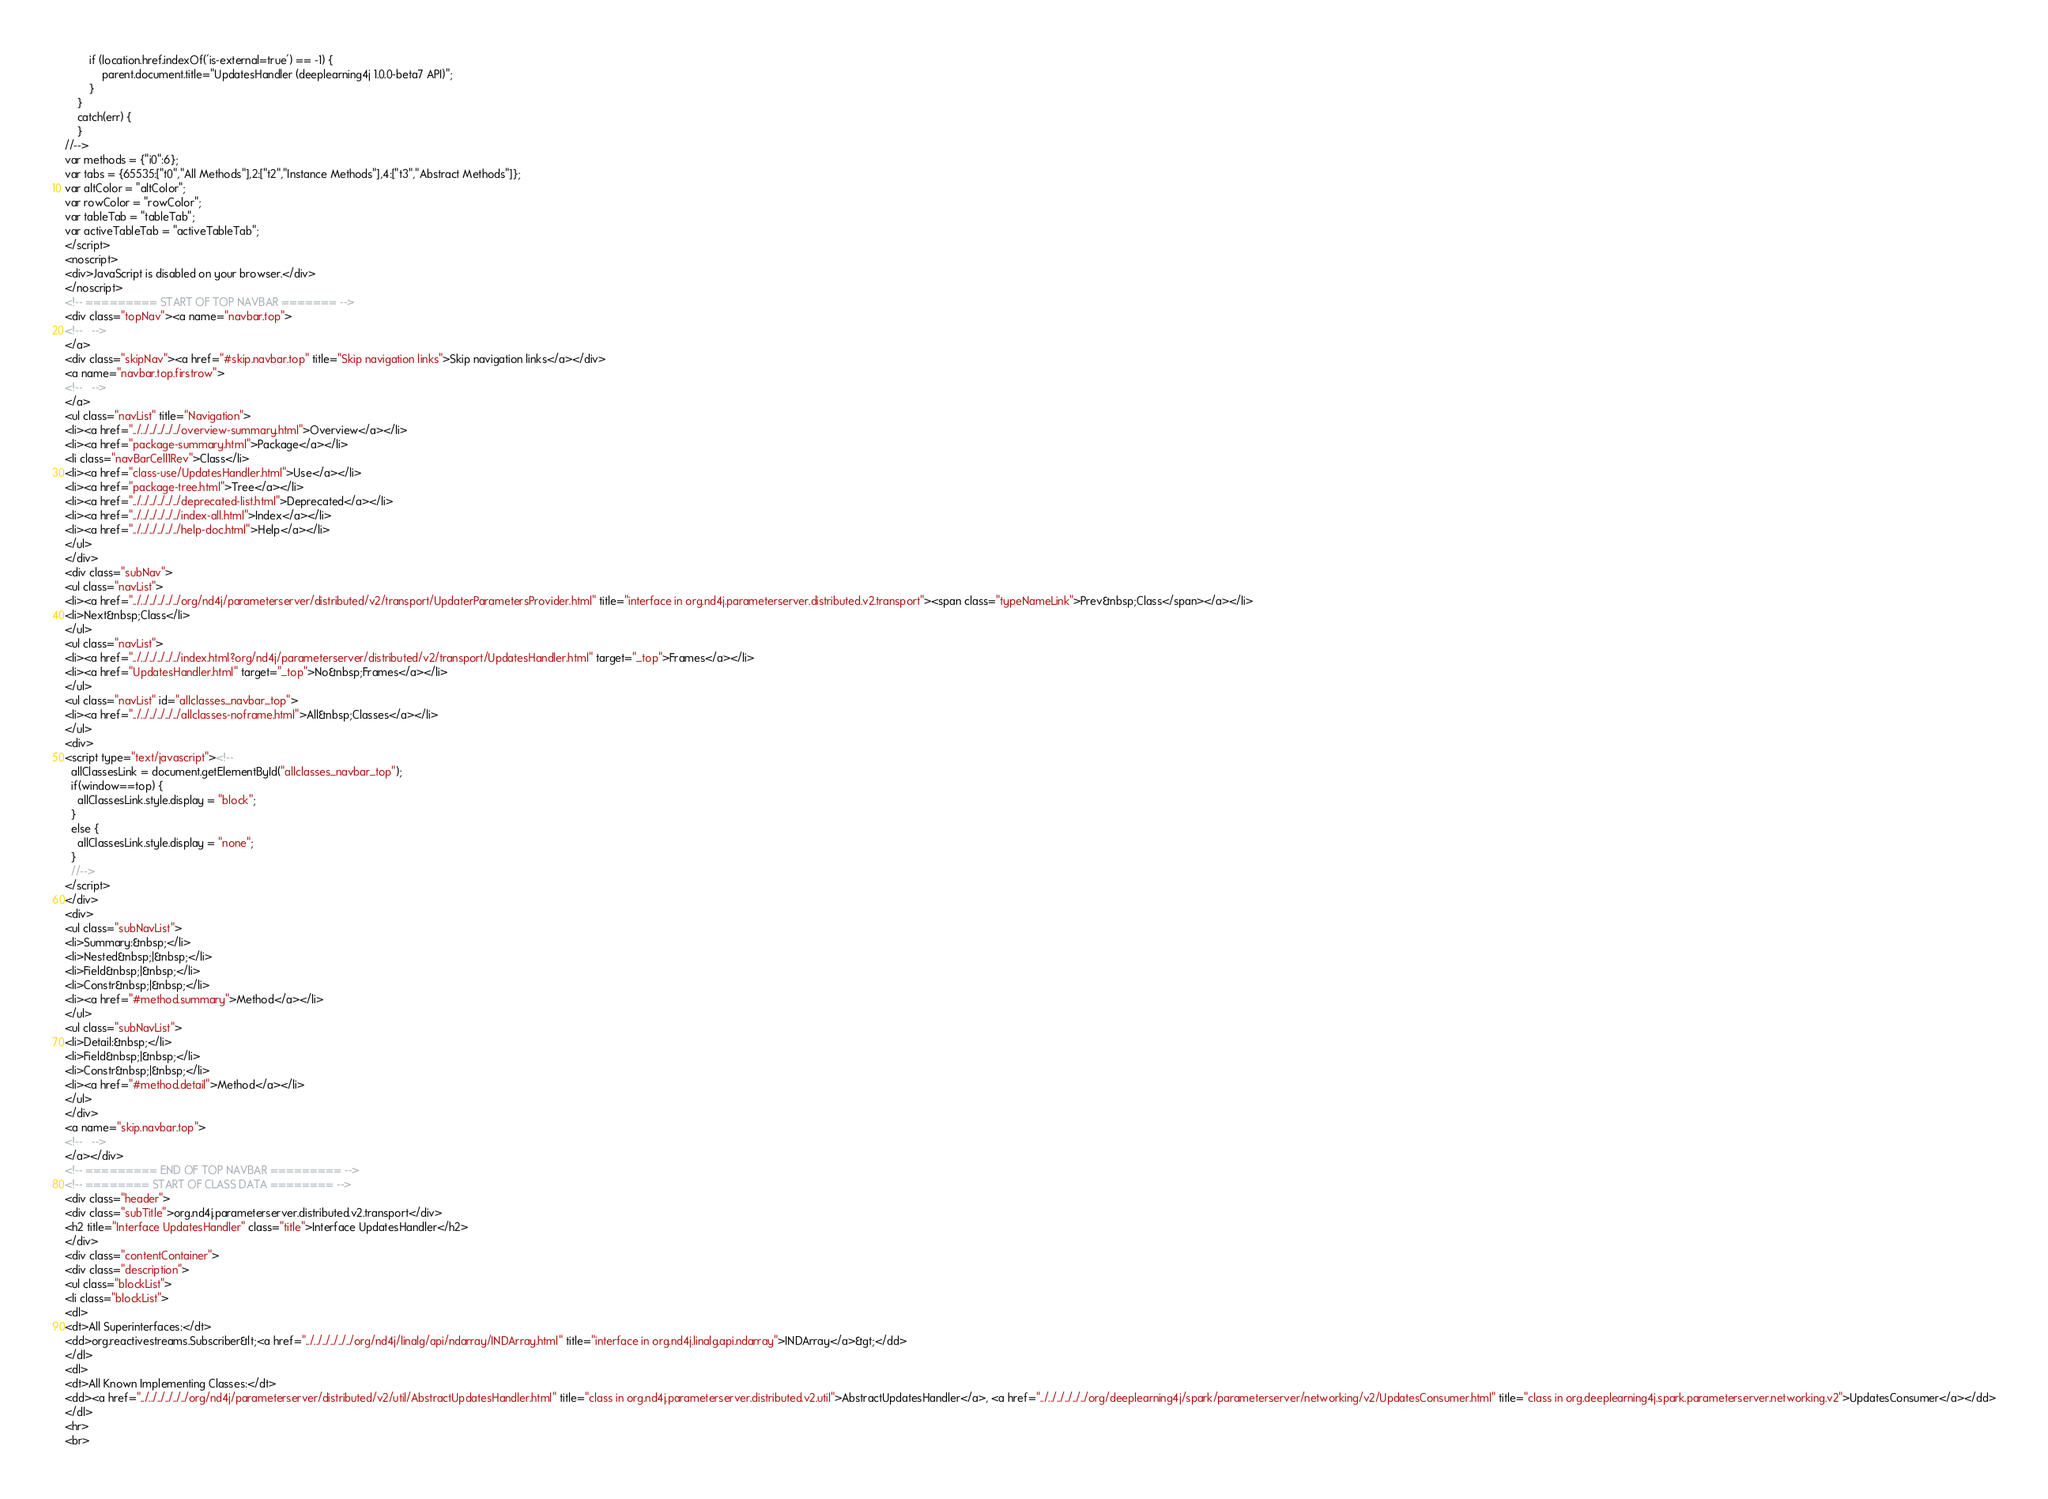<code> <loc_0><loc_0><loc_500><loc_500><_HTML_>        if (location.href.indexOf('is-external=true') == -1) {
            parent.document.title="UpdatesHandler (deeplearning4j 1.0.0-beta7 API)";
        }
    }
    catch(err) {
    }
//-->
var methods = {"i0":6};
var tabs = {65535:["t0","All Methods"],2:["t2","Instance Methods"],4:["t3","Abstract Methods"]};
var altColor = "altColor";
var rowColor = "rowColor";
var tableTab = "tableTab";
var activeTableTab = "activeTableTab";
</script>
<noscript>
<div>JavaScript is disabled on your browser.</div>
</noscript>
<!-- ========= START OF TOP NAVBAR ======= -->
<div class="topNav"><a name="navbar.top">
<!--   -->
</a>
<div class="skipNav"><a href="#skip.navbar.top" title="Skip navigation links">Skip navigation links</a></div>
<a name="navbar.top.firstrow">
<!--   -->
</a>
<ul class="navList" title="Navigation">
<li><a href="../../../../../../overview-summary.html">Overview</a></li>
<li><a href="package-summary.html">Package</a></li>
<li class="navBarCell1Rev">Class</li>
<li><a href="class-use/UpdatesHandler.html">Use</a></li>
<li><a href="package-tree.html">Tree</a></li>
<li><a href="../../../../../../deprecated-list.html">Deprecated</a></li>
<li><a href="../../../../../../index-all.html">Index</a></li>
<li><a href="../../../../../../help-doc.html">Help</a></li>
</ul>
</div>
<div class="subNav">
<ul class="navList">
<li><a href="../../../../../../org/nd4j/parameterserver/distributed/v2/transport/UpdaterParametersProvider.html" title="interface in org.nd4j.parameterserver.distributed.v2.transport"><span class="typeNameLink">Prev&nbsp;Class</span></a></li>
<li>Next&nbsp;Class</li>
</ul>
<ul class="navList">
<li><a href="../../../../../../index.html?org/nd4j/parameterserver/distributed/v2/transport/UpdatesHandler.html" target="_top">Frames</a></li>
<li><a href="UpdatesHandler.html" target="_top">No&nbsp;Frames</a></li>
</ul>
<ul class="navList" id="allclasses_navbar_top">
<li><a href="../../../../../../allclasses-noframe.html">All&nbsp;Classes</a></li>
</ul>
<div>
<script type="text/javascript"><!--
  allClassesLink = document.getElementById("allclasses_navbar_top");
  if(window==top) {
    allClassesLink.style.display = "block";
  }
  else {
    allClassesLink.style.display = "none";
  }
  //-->
</script>
</div>
<div>
<ul class="subNavList">
<li>Summary:&nbsp;</li>
<li>Nested&nbsp;|&nbsp;</li>
<li>Field&nbsp;|&nbsp;</li>
<li>Constr&nbsp;|&nbsp;</li>
<li><a href="#method.summary">Method</a></li>
</ul>
<ul class="subNavList">
<li>Detail:&nbsp;</li>
<li>Field&nbsp;|&nbsp;</li>
<li>Constr&nbsp;|&nbsp;</li>
<li><a href="#method.detail">Method</a></li>
</ul>
</div>
<a name="skip.navbar.top">
<!--   -->
</a></div>
<!-- ========= END OF TOP NAVBAR ========= -->
<!-- ======== START OF CLASS DATA ======== -->
<div class="header">
<div class="subTitle">org.nd4j.parameterserver.distributed.v2.transport</div>
<h2 title="Interface UpdatesHandler" class="title">Interface UpdatesHandler</h2>
</div>
<div class="contentContainer">
<div class="description">
<ul class="blockList">
<li class="blockList">
<dl>
<dt>All Superinterfaces:</dt>
<dd>org.reactivestreams.Subscriber&lt;<a href="../../../../../../org/nd4j/linalg/api/ndarray/INDArray.html" title="interface in org.nd4j.linalg.api.ndarray">INDArray</a>&gt;</dd>
</dl>
<dl>
<dt>All Known Implementing Classes:</dt>
<dd><a href="../../../../../../org/nd4j/parameterserver/distributed/v2/util/AbstractUpdatesHandler.html" title="class in org.nd4j.parameterserver.distributed.v2.util">AbstractUpdatesHandler</a>, <a href="../../../../../../org/deeplearning4j/spark/parameterserver/networking/v2/UpdatesConsumer.html" title="class in org.deeplearning4j.spark.parameterserver.networking.v2">UpdatesConsumer</a></dd>
</dl>
<hr>
<br></code> 